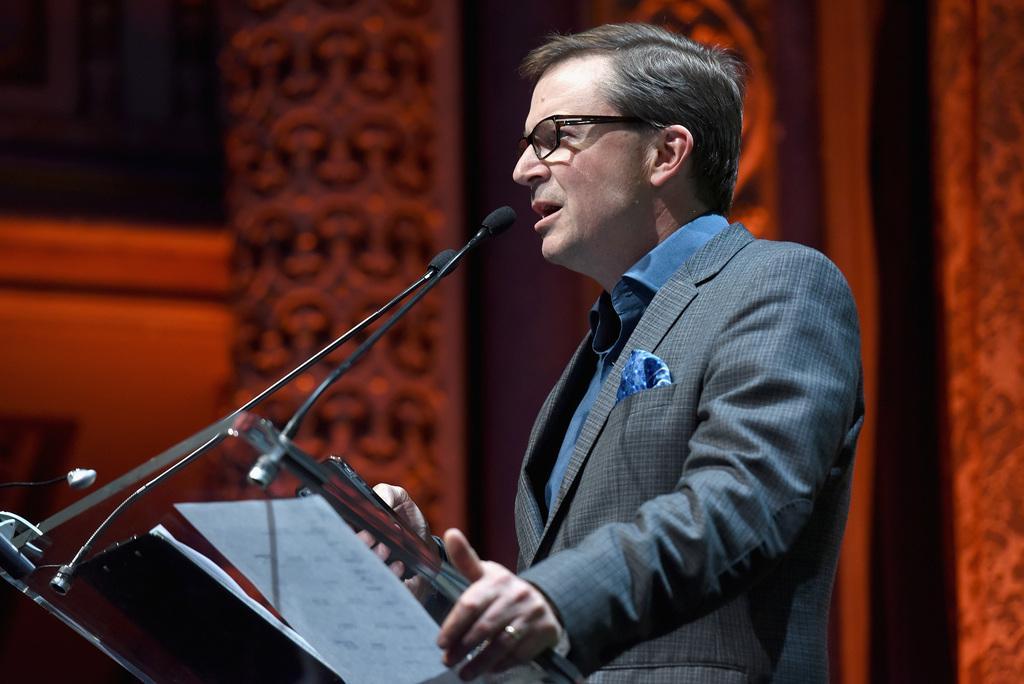Please provide a concise description of this image. In the image there is a man standing and speaking something, there is a table in front of him and on the table there is a mic and some papers, the background of the man is blur. 